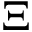<formula> <loc_0><loc_0><loc_500><loc_500>\Xi</formula> 